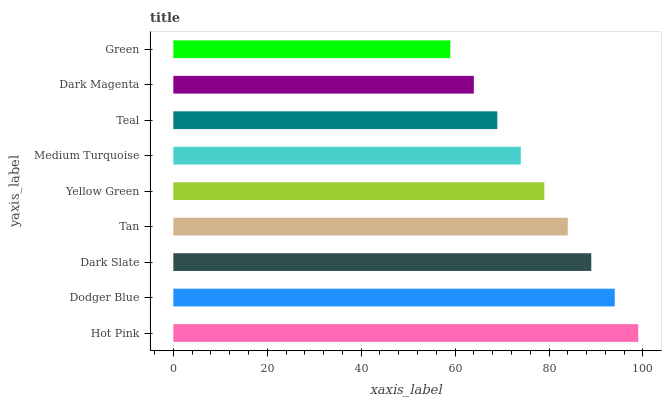Is Green the minimum?
Answer yes or no. Yes. Is Hot Pink the maximum?
Answer yes or no. Yes. Is Dodger Blue the minimum?
Answer yes or no. No. Is Dodger Blue the maximum?
Answer yes or no. No. Is Hot Pink greater than Dodger Blue?
Answer yes or no. Yes. Is Dodger Blue less than Hot Pink?
Answer yes or no. Yes. Is Dodger Blue greater than Hot Pink?
Answer yes or no. No. Is Hot Pink less than Dodger Blue?
Answer yes or no. No. Is Yellow Green the high median?
Answer yes or no. Yes. Is Yellow Green the low median?
Answer yes or no. Yes. Is Dodger Blue the high median?
Answer yes or no. No. Is Teal the low median?
Answer yes or no. No. 